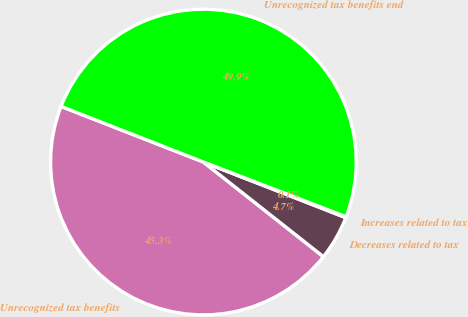Convert chart to OTSL. <chart><loc_0><loc_0><loc_500><loc_500><pie_chart><fcel>Unrecognized tax benefits<fcel>Decreases related to tax<fcel>Increases related to tax<fcel>Unrecognized tax benefits end<nl><fcel>45.3%<fcel>4.7%<fcel>0.1%<fcel>49.9%<nl></chart> 